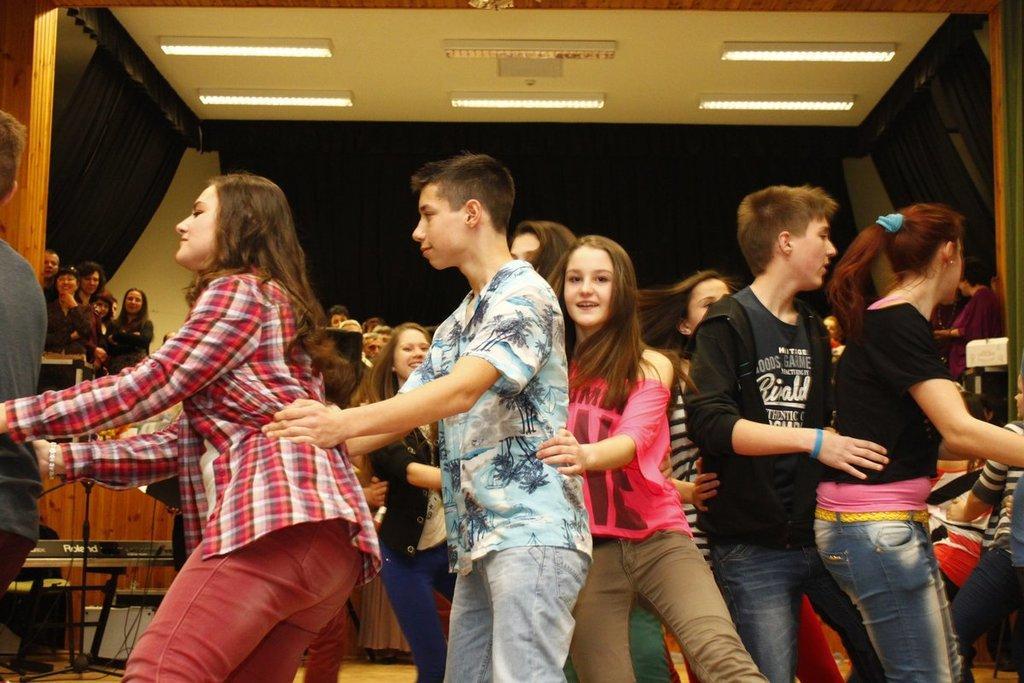Describe this image in one or two sentences. In this image I can see the group of people are wearing different color dresses. I can see few objects, lights, wall and the curtains. 